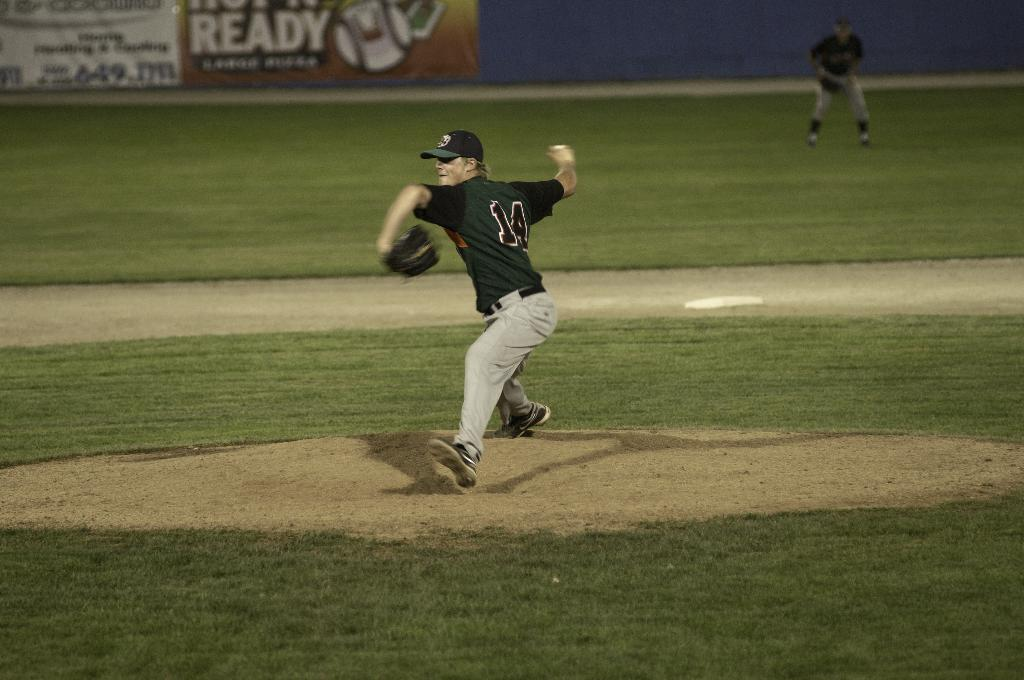<image>
Share a concise interpretation of the image provided. the number 14 is on the back of a jersey 